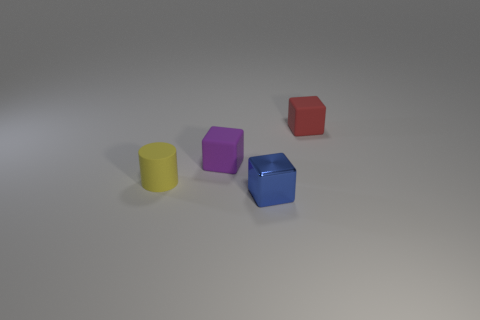Which object stands out the most and why? The blue hexagonal prism stands out due to its unique shape with a hexagonal top surface, which differs from the otherwise standard shapes like cylinders and cubes. Additionally, its position in the center and its bright blue color draw the viewer's attention. Could you guess the possible size of these objects? While the image does not provide a reference scale, the objects appear to be quite small, possibly the size of standard building blocks or dice, which could be comfortably held in one's hand. 